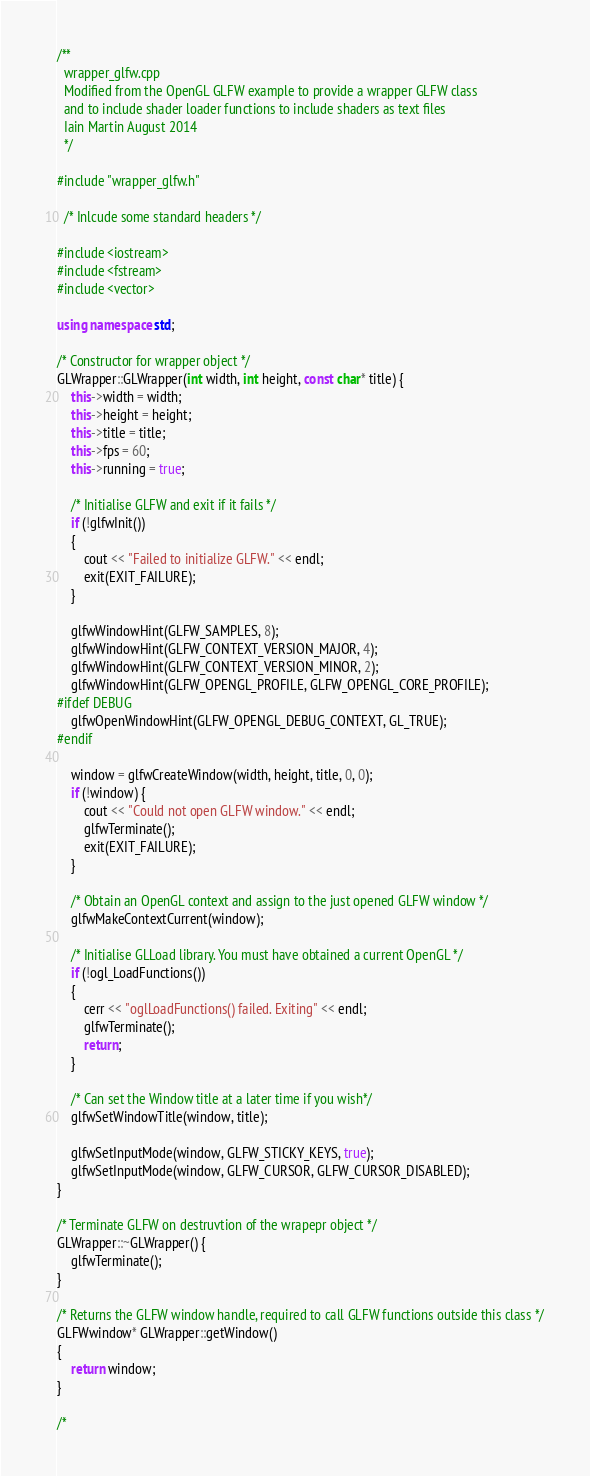<code> <loc_0><loc_0><loc_500><loc_500><_C++_>/**
  wrapper_glfw.cpp
  Modified from the OpenGL GLFW example to provide a wrapper GLFW class
  and to include shader loader functions to include shaders as text files
  Iain Martin August 2014
  */

#include "wrapper_glfw.h"

  /* Inlcude some standard headers */

#include <iostream>
#include <fstream>
#include <vector>

using namespace std;

/* Constructor for wrapper object */
GLWrapper::GLWrapper(int width, int height, const char* title) {
	this->width = width;
	this->height = height;
	this->title = title;
	this->fps = 60;
	this->running = true;

	/* Initialise GLFW and exit if it fails */
	if (!glfwInit())
	{
		cout << "Failed to initialize GLFW." << endl;
		exit(EXIT_FAILURE);
	}

	glfwWindowHint(GLFW_SAMPLES, 8);
	glfwWindowHint(GLFW_CONTEXT_VERSION_MAJOR, 4);
	glfwWindowHint(GLFW_CONTEXT_VERSION_MINOR, 2);
	glfwWindowHint(GLFW_OPENGL_PROFILE, GLFW_OPENGL_CORE_PROFILE);
#ifdef DEBUG
	glfwOpenWindowHint(GLFW_OPENGL_DEBUG_CONTEXT, GL_TRUE);
#endif

	window = glfwCreateWindow(width, height, title, 0, 0);
	if (!window) {
		cout << "Could not open GLFW window." << endl;
		glfwTerminate();
		exit(EXIT_FAILURE);
	}

	/* Obtain an OpenGL context and assign to the just opened GLFW window */
	glfwMakeContextCurrent(window);

	/* Initialise GLLoad library. You must have obtained a current OpenGL */
	if (!ogl_LoadFunctions())
	{
		cerr << "oglLoadFunctions() failed. Exiting" << endl;
		glfwTerminate();
		return;
	}

	/* Can set the Window title at a later time if you wish*/
	glfwSetWindowTitle(window, title);

	glfwSetInputMode(window, GLFW_STICKY_KEYS, true);
	glfwSetInputMode(window, GLFW_CURSOR, GLFW_CURSOR_DISABLED);
}

/* Terminate GLFW on destruvtion of the wrapepr object */
GLWrapper::~GLWrapper() {
	glfwTerminate();
}

/* Returns the GLFW window handle, required to call GLFW functions outside this class */
GLFWwindow* GLWrapper::getWindow()
{
	return window;
}

/*</code> 